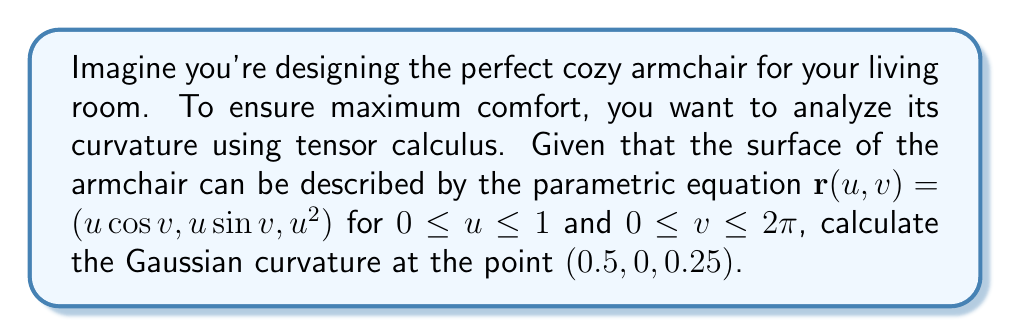Provide a solution to this math problem. To calculate the Gaussian curvature, we'll follow these steps:

1) First, we need to calculate the first fundamental form coefficients E, F, and G:

   $\mathbf{r}_u = (\cos v, \sin v, 2u)$
   $\mathbf{r}_v = (-u\sin v, u\cos v, 0)$

   $E = \mathbf{r}_u \cdot \mathbf{r}_u = \cos^2 v + \sin^2 v + 4u^2 = 1 + 4u^2$
   $F = \mathbf{r}_u \cdot \mathbf{r}_v = 0$
   $G = \mathbf{r}_v \cdot \mathbf{r}_v = u^2$

2) Next, we calculate the second fundamental form coefficients e, f, and g:

   $\mathbf{r}_{uu} = (0, 0, 2)$
   $\mathbf{r}_{uv} = (-\sin v, \cos v, 0)$
   $\mathbf{r}_{vv} = (-u\cos v, -u\sin v, 0)$

   $\mathbf{N} = \frac{\mathbf{r}_u \times \mathbf{r}_v}{|\mathbf{r}_u \times \mathbf{r}_v|} = \frac{(-2u\cos v, -2u\sin v, 1)}{\sqrt{1 + 4u^2}}$

   $e = \mathbf{r}_{uu} \cdot \mathbf{N} = \frac{2}{\sqrt{1 + 4u^2}}$
   $f = \mathbf{r}_{uv} \cdot \mathbf{N} = 0$
   $g = \mathbf{r}_{vv} \cdot \mathbf{N} = \frac{-u}{\sqrt{1 + 4u^2}}$

3) The Gaussian curvature K is given by:

   $K = \frac{eg - f^2}{EG - F^2}$

4) Substituting our values:

   $K = \frac{(\frac{2}{\sqrt{1 + 4u^2}})(\frac{-u}{\sqrt{1 + 4u^2}}) - 0^2}{(1 + 4u^2)(u^2) - 0^2}$

5) Simplifying:

   $K = \frac{-2u}{(1 + 4u^2)^2u^2} = \frac{-2}{u(1 + 4u^2)^2}$

6) At the point $(0.5, 0, 0.25)$, $u = 0.5$. Substituting this value:

   $K = \frac{-2}{0.5(1 + 4(0.5)^2)^2} = \frac{-2}{0.5(2)^2} = \frac{-2}{2} = -1$

Therefore, the Gaussian curvature at the point $(0.5, 0, 0.25)$ is -1.
Answer: $K = -1$ 